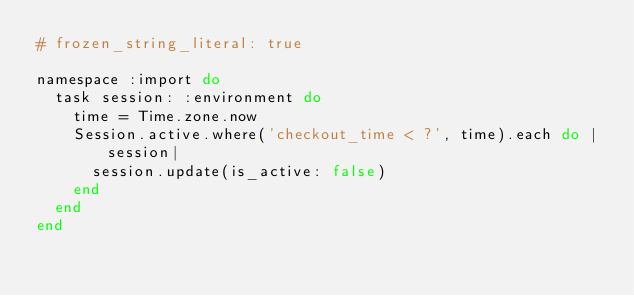Convert code to text. <code><loc_0><loc_0><loc_500><loc_500><_Ruby_># frozen_string_literal: true

namespace :import do
  task session: :environment do
    time = Time.zone.now
    Session.active.where('checkout_time < ?', time).each do |session|
      session.update(is_active: false)
    end
  end
end
</code> 